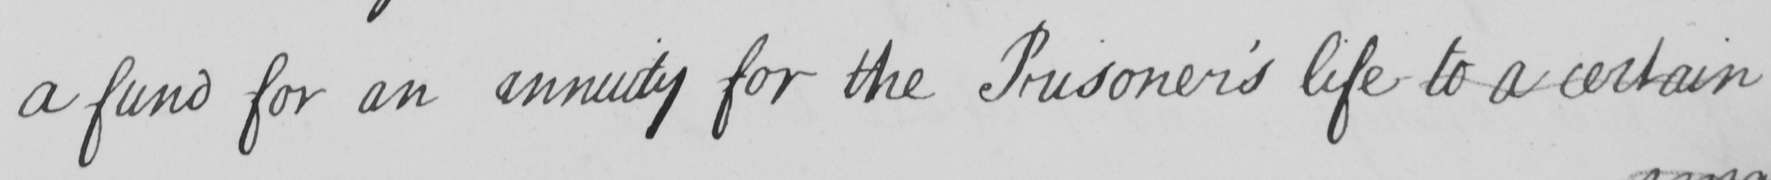Please provide the text content of this handwritten line. a fund for an annuity for the Prisoner ' s life to a certain 